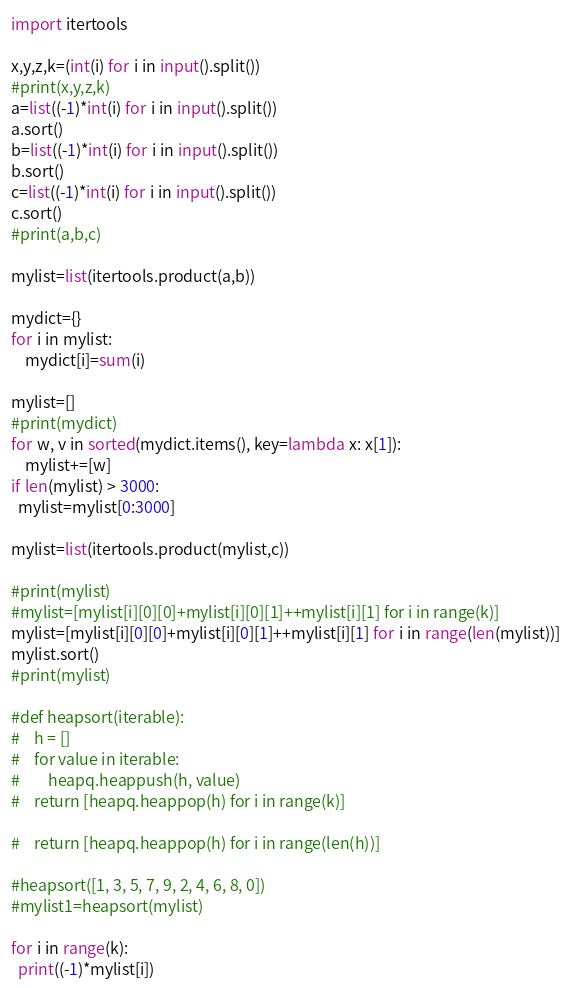Convert code to text. <code><loc_0><loc_0><loc_500><loc_500><_Python_>import itertools

x,y,z,k=(int(i) for i in input().split())
#print(x,y,z,k)
a=list((-1)*int(i) for i in input().split())
a.sort()
b=list((-1)*int(i) for i in input().split())
b.sort()
c=list((-1)*int(i) for i in input().split())
c.sort()
#print(a,b,c)

mylist=list(itertools.product(a,b))

mydict={}
for i in mylist:
    mydict[i]=sum(i)

mylist=[]
#print(mydict)
for w, v in sorted(mydict.items(), key=lambda x: x[1]):
    mylist+=[w]
if len(mylist) > 3000:
  mylist=mylist[0:3000]
    
mylist=list(itertools.product(mylist,c))

#print(mylist)
#mylist=[mylist[i][0][0]+mylist[i][0][1]++mylist[i][1] for i in range(k)]
mylist=[mylist[i][0][0]+mylist[i][0][1]++mylist[i][1] for i in range(len(mylist))]
mylist.sort()
#print(mylist)

#def heapsort(iterable):
#    h = []
#    for value in iterable:
#        heapq.heappush(h, value)
#    return [heapq.heappop(h) for i in range(k)]

#    return [heapq.heappop(h) for i in range(len(h))]

#heapsort([1, 3, 5, 7, 9, 2, 4, 6, 8, 0])
#mylist1=heapsort(mylist)

for i in range(k):
  print((-1)*mylist[i])
</code> 